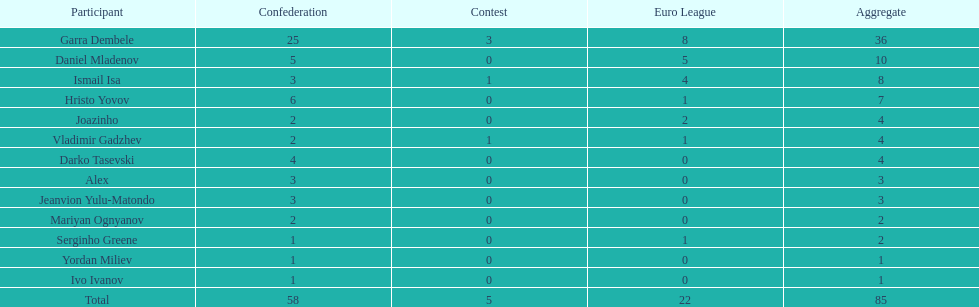How many players had a total of 4? 3. 